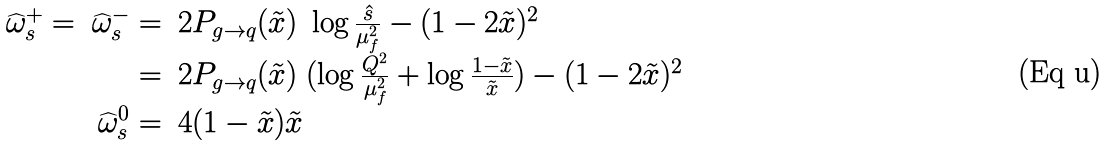Convert formula to latex. <formula><loc_0><loc_0><loc_500><loc_500>\begin{array} { r r l } \widehat { \omega } _ { s } ^ { + } = & \widehat { \omega } _ { s } ^ { - } = & 2 P _ { g \to q } ( \tilde { x } ) \ \log \frac { \hat { s } } { \mu _ { f } ^ { 2 } } - ( 1 - 2 \tilde { x } ) ^ { 2 } \\ & = & 2 P _ { g \to q } ( \tilde { x } ) \ ( \log \frac { Q ^ { 2 } } { \mu _ { f } ^ { 2 } } + \log \frac { 1 - \tilde { x } } { \tilde { x } } ) - ( 1 - 2 \tilde { x } ) ^ { 2 } \\ & \widehat { \omega } _ { s } ^ { 0 } = & 4 ( 1 - \tilde { x } ) \tilde { x } \end{array}</formula> 